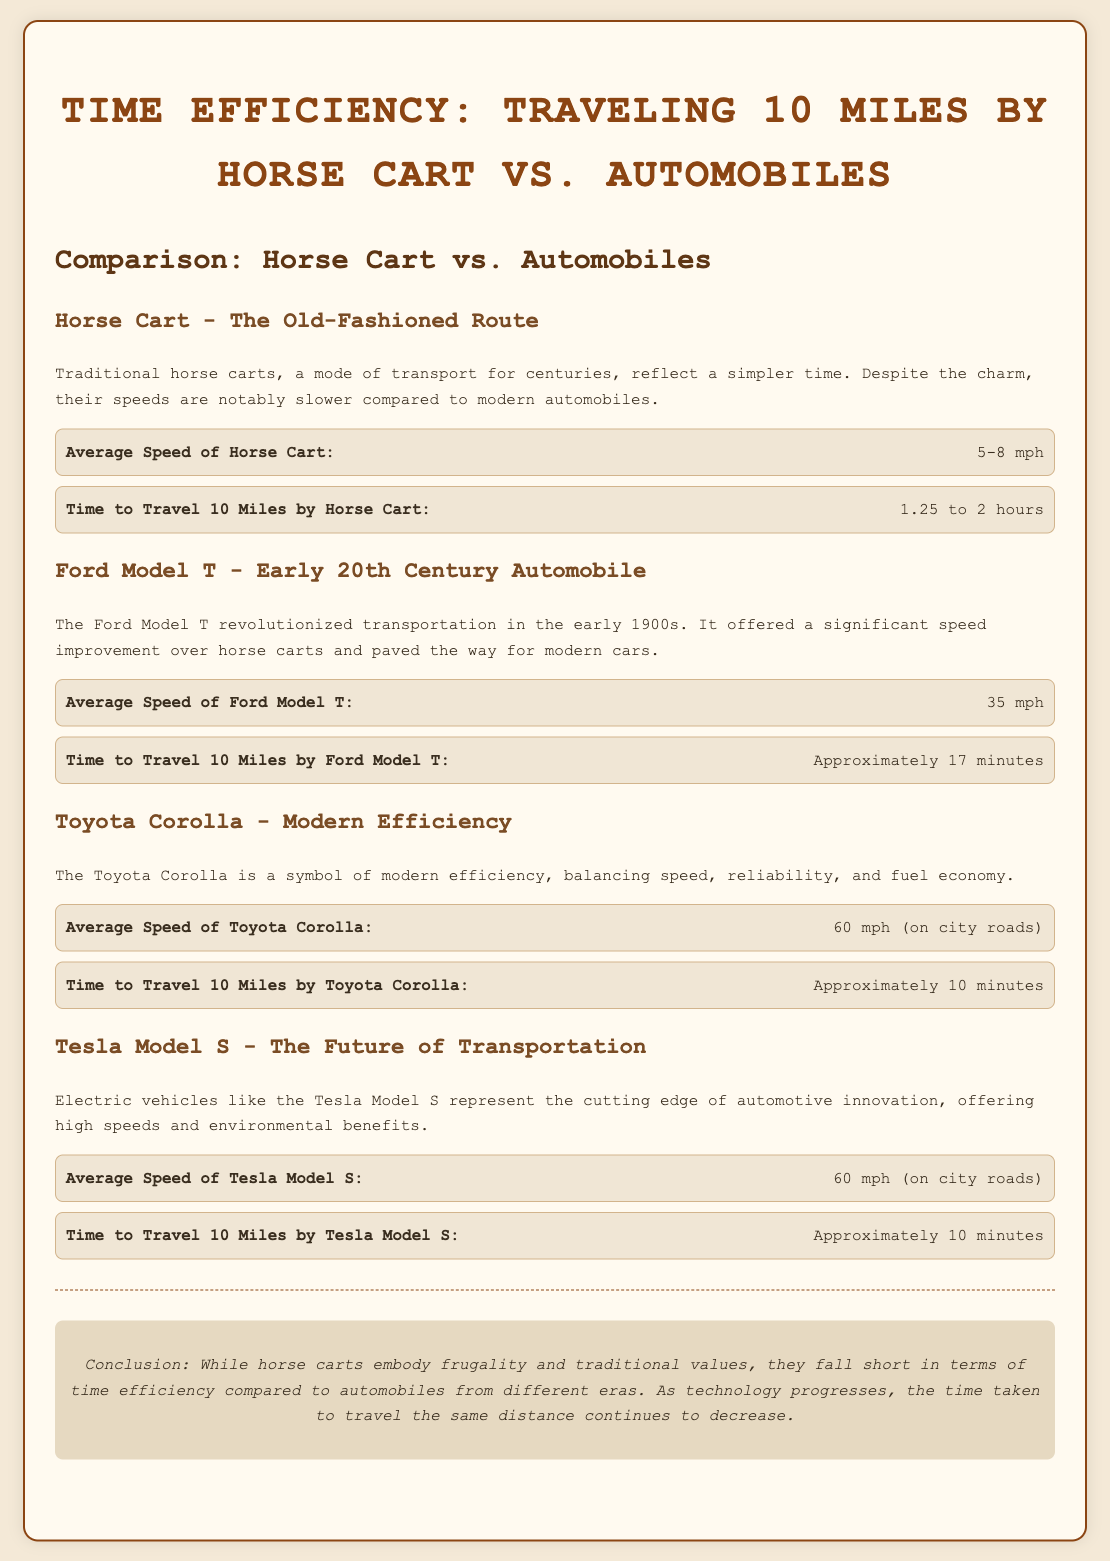What is the average speed of a horse cart? The average speed of a horse cart is stated as 5-8 mph.
Answer: 5-8 mph How long does it take to travel 10 miles by Ford Model T? The time to travel 10 miles by Ford Model T is approximately 17 minutes.
Answer: Approximately 17 minutes What is the average speed of a Toyota Corolla? The average speed of a Toyota Corolla is noted as 60 mph (on city roads).
Answer: 60 mph (on city roads) What is the time taken to travel 10 miles with the Tesla Model S? The time to travel 10 miles by Tesla Model S is also approximately 10 minutes.
Answer: Approximately 10 minutes Which mode of transport takes the longest time for 10 miles? The comparison indicates that the horse cart takes the longest time for 10 miles.
Answer: Horse cart What is the key characteristic of the Toyota Corolla mentioned in the document? The document describes the Toyota Corolla as a symbol of modern efficiency, balancing speed, reliability, and fuel economy.
Answer: Modern efficiency How does the conclusion summarize the comparison of transportation methods? The conclusion states that while horse carts embody frugality and traditional values, they fall short in terms of time efficiency compared to automobiles.
Answer: Fall short in time efficiency What type of transportation does the Tesla Model S represent? The document classifies the Tesla Model S as representing the future of transportation and automotive innovation.
Answer: The future of transportation 